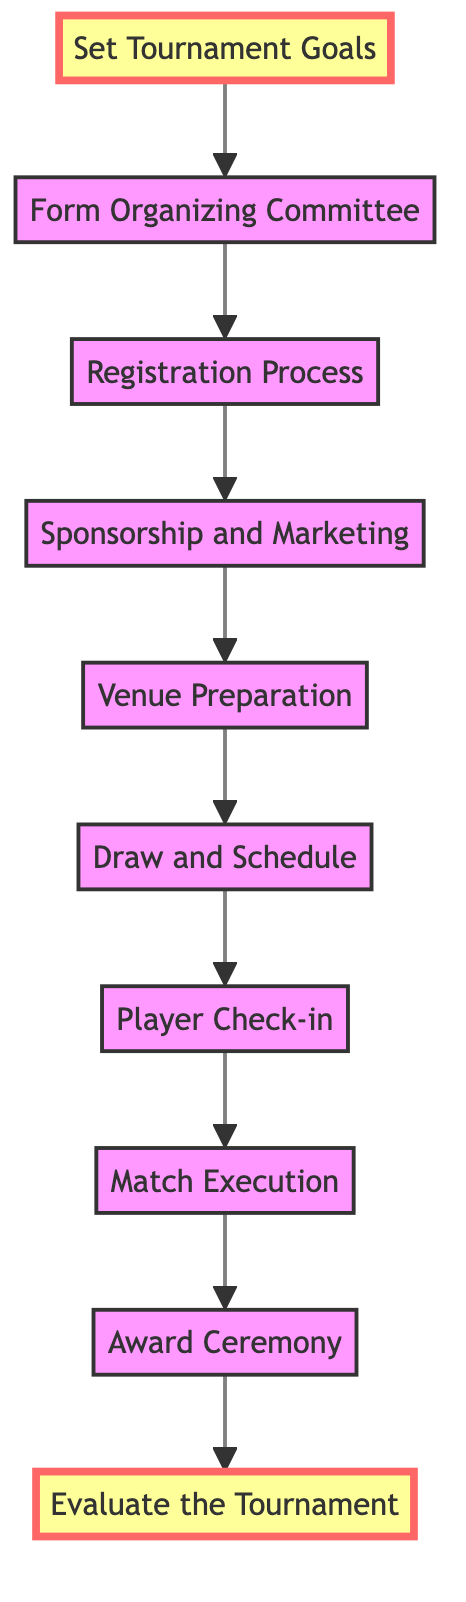What is the first step in organizing a tennis tournament? The diagram starts with "Set Tournament Goals," indicating it is the first step in the flow of organizing a tennis tournament.
Answer: Set Tournament Goals How many total steps are involved in the tournament organization process? The diagram lists ten distinct steps from "Set Tournament Goals" to "Evaluate the Tournament," which shows there are ten steps in total.
Answer: Ten What follows after "Registration Process"? According to the flow, "Sponsorship and Marketing" is directly after "Registration Process," as it is the next step in the tournament organization sequence.
Answer: Sponsorship and Marketing Which step occurs just before the award ceremony? The step "Match Execution" takes place immediately before the "Award Ceremony," according to the sequence shown in the diagram.
Answer: Match Execution What is the last step in the process of organizing a tennis tournament? The final step in the flow is "Evaluate the Tournament," indicating it is the concluding part of the organization process.
Answer: Evaluate the Tournament Which step is responsible for venue-related preparations? "Venue Preparation" is the step that focuses on preparing the courts, seating, and facilities, as outlined in the diagram.
Answer: Venue Preparation What is the relationship between "Form Organizing Committee" and "Sponsorship and Marketing"? The flow indicates that "Form Organizing Committee" precedes "Sponsorship and Marketing," establishing that the committee is formed before seeking sponsorships for the event.
Answer: Form Organizing Committee precedes Sponsorship and Marketing How many steps are there between "Set Tournament Goals" and "Match Execution"? There are six steps between "Set Tournament Goals" and "Match Execution" as we count each step in the flow leading up to Match Execution: (1) Form Organizing Committee, (2) Registration Process, (3) Sponsorship and Marketing, (4) Venue Preparation, (5) Draw and Schedule, and (6) Player Check-in.
Answer: Six steps What step comes directly after "Player Check-in"? The step that comes after "Player Check-in" is "Match Execution," indicating that player check-ins are completed before the matches begin.
Answer: Match Execution 